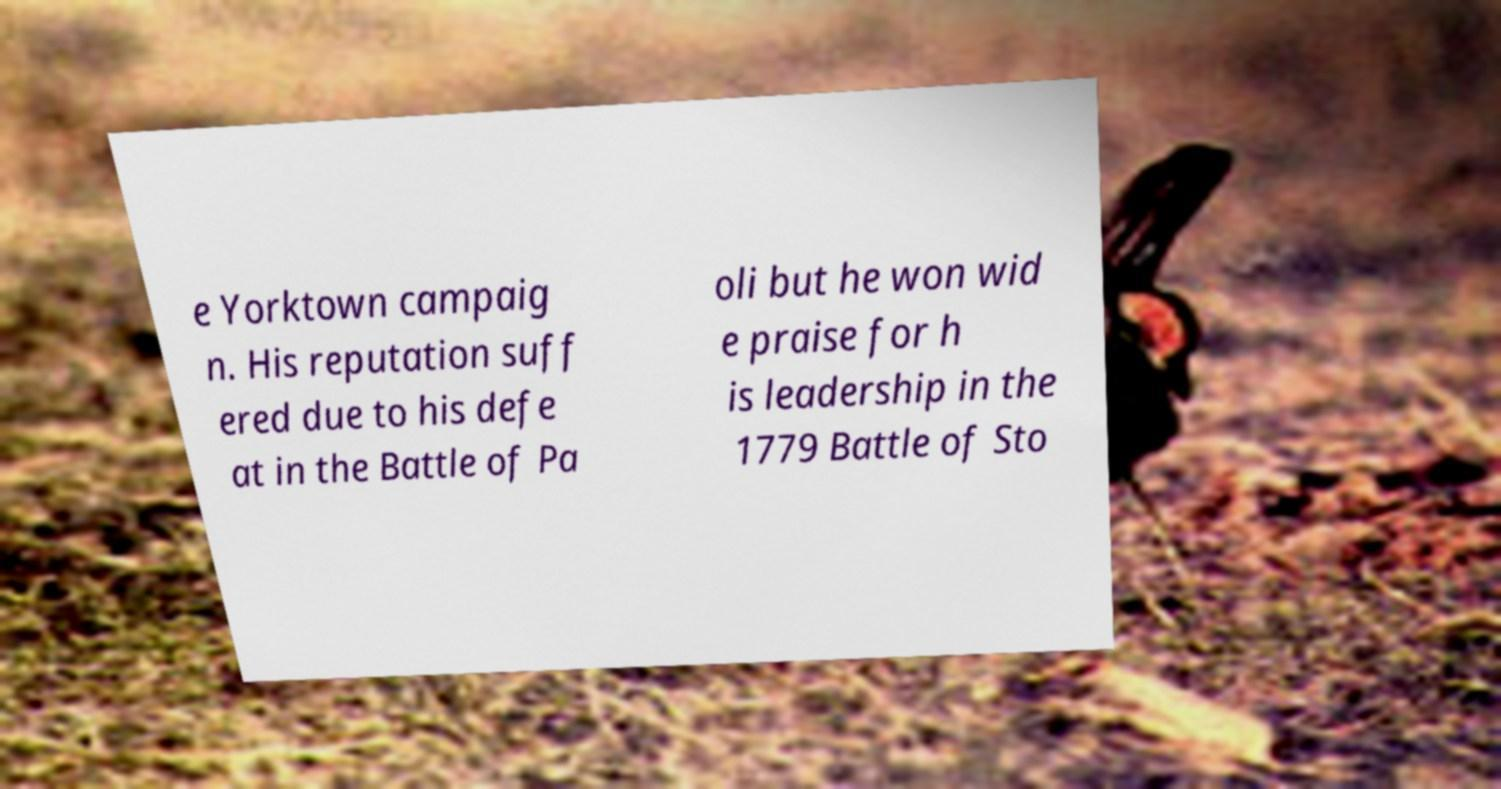Please read and relay the text visible in this image. What does it say? e Yorktown campaig n. His reputation suff ered due to his defe at in the Battle of Pa oli but he won wid e praise for h is leadership in the 1779 Battle of Sto 